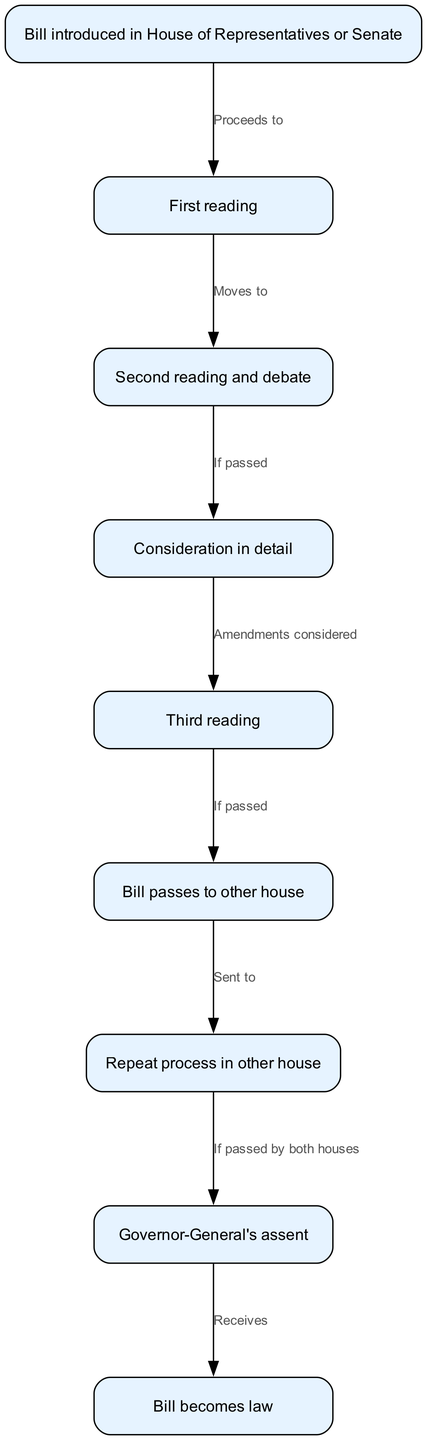What is the first step in the process? The first step in the process as depicted in the diagram is "Bill introduced in House of Representatives or Senate." This is the initial node and represents where the journey of a bill begins.
Answer: Bill introduced in House of Representatives or Senate How many nodes are there in total? The diagram lists a total of 9 nodes, which represent the stages of the legislative process for a bill as it becomes law.
Answer: 9 What happens after the first reading? After the first reading, the process moves to the "Second reading and debate." This is the next stage that occurs in the legislative process.
Answer: Second reading and debate What is the condition to proceed from the second reading to the consideration in detail? The condition to proceed from the second reading to the consideration in detail is that the bill must be passed during the second reading. This is stated in the edge connecting these two nodes.
Answer: If passed What step occurs after the bill passes to the other house? After the bill passes to the other house, it requires the "Repeat process in other house" to go through similar stages as it did in the first house.
Answer: Repeat process in other house What is necessary for the bill to receive the Governor-General's assent? For the bill to receive the Governor-General's assent, it must be passed by both houses, establishing the key condition necessary for this step of the process.
Answer: If passed by both houses In which stage does the bill become law? The bill becomes law after it receives the Governor-General's assent, as indicated in the diagram. This is the final node representing the successful conclusion of the legislative process.
Answer: Bill becomes law 